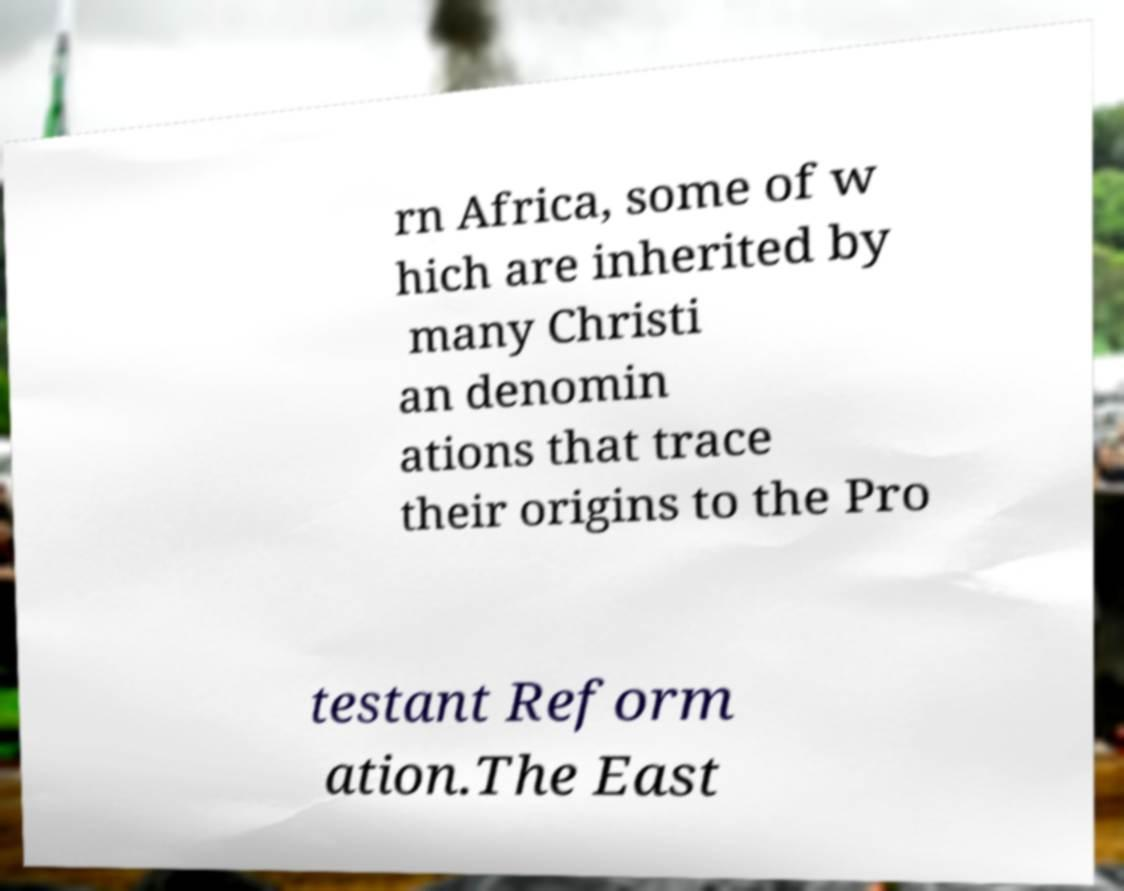I need the written content from this picture converted into text. Can you do that? rn Africa, some of w hich are inherited by many Christi an denomin ations that trace their origins to the Pro testant Reform ation.The East 